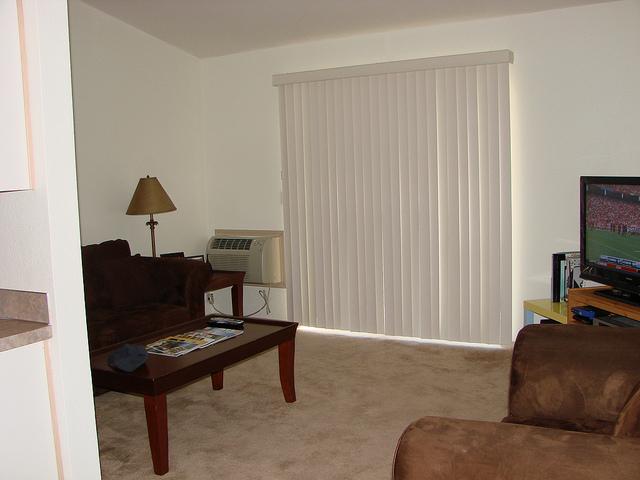What color is the armchair?
Concise answer only. Brown. Is the tv on?
Concise answer only. Yes. What sport is on the television?
Answer briefly. Football. What is sitting on top of the crate?
Short answer required. Tv. What color are the walls?
Write a very short answer. White. What color can you see clearly on the coffee table in the?
Short answer required. Brown. Is this someone's house?
Be succinct. Yes. Is anyone sitting on the sofa?
Be succinct. No. 